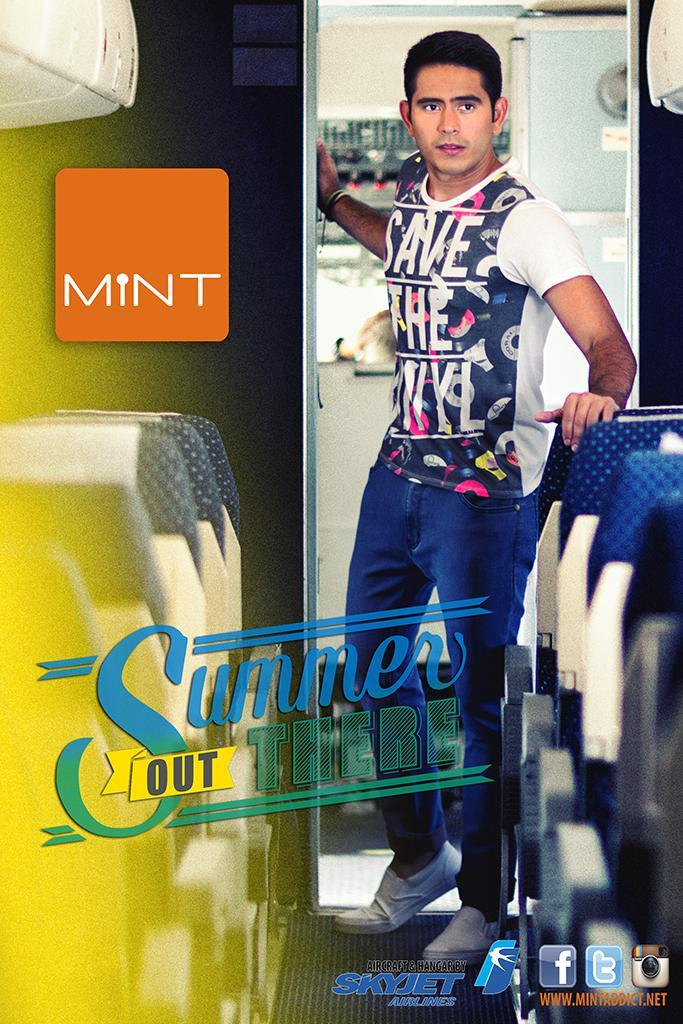<image>
Create a compact narrative representing the image presented. An advertisement from mint declares that summer is out there. 